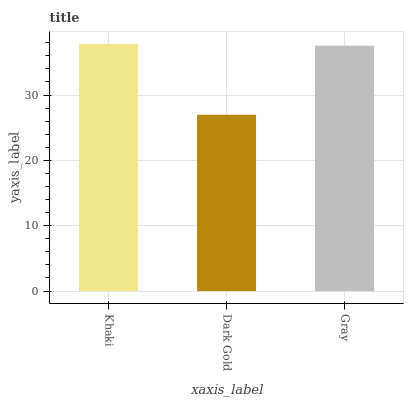Is Dark Gold the minimum?
Answer yes or no. Yes. Is Khaki the maximum?
Answer yes or no. Yes. Is Gray the minimum?
Answer yes or no. No. Is Gray the maximum?
Answer yes or no. No. Is Gray greater than Dark Gold?
Answer yes or no. Yes. Is Dark Gold less than Gray?
Answer yes or no. Yes. Is Dark Gold greater than Gray?
Answer yes or no. No. Is Gray less than Dark Gold?
Answer yes or no. No. Is Gray the high median?
Answer yes or no. Yes. Is Gray the low median?
Answer yes or no. Yes. Is Khaki the high median?
Answer yes or no. No. Is Dark Gold the low median?
Answer yes or no. No. 